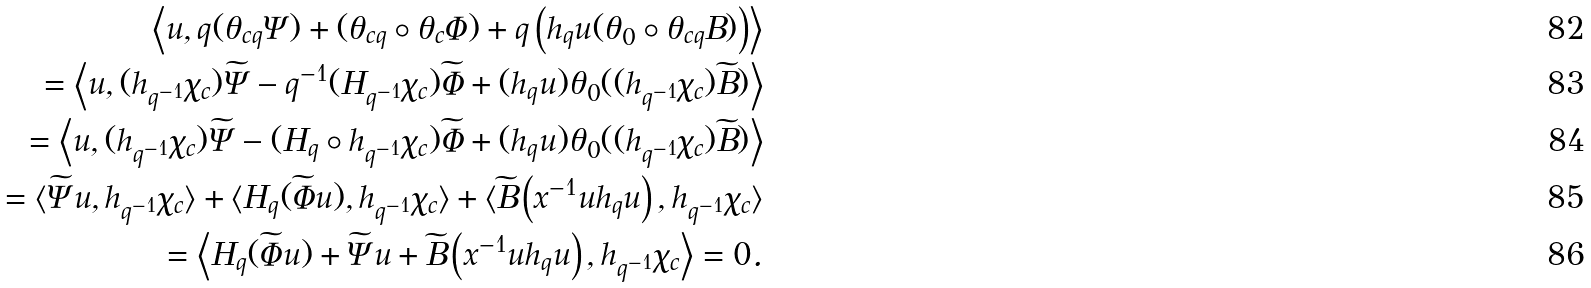Convert formula to latex. <formula><loc_0><loc_0><loc_500><loc_500>\left \langle u , q ( \theta _ { c q } \Psi ) + ( \theta _ { c q } \circ \theta _ { c } \Phi ) + q \left ( h _ { q } u ( \theta _ { 0 } \circ \theta _ { c q } B ) \right ) \right \rangle \\ = \left \langle u , ( h _ { q ^ { - 1 } } \chi _ { c } ) \widetilde { \Psi } - q ^ { - 1 } ( H _ { q ^ { - 1 } } \chi _ { c } ) \widetilde { \Phi } + ( h _ { q } u ) \theta _ { 0 } ( ( h _ { q ^ { - 1 } } \chi _ { c } ) \widetilde { B } ) \right \rangle \\ = \left \langle u , ( h _ { q ^ { - 1 } } \chi _ { c } ) \widetilde { \Psi } - ( H _ { q } \circ h _ { q ^ { - 1 } } \chi _ { c } ) \widetilde { \Phi } + ( h _ { q } u ) \theta _ { 0 } ( ( h _ { q ^ { - 1 } } \chi _ { c } ) \widetilde { B } ) \right \rangle \\ = \langle \widetilde { \Psi } u , h _ { q ^ { - 1 } } \chi _ { c } \rangle + \langle H _ { q } ( \widetilde { \Phi } u ) , h _ { q ^ { - 1 } } \chi _ { c } \rangle + \langle \widetilde { B } \left ( x ^ { - 1 } u h _ { q } u \right ) , h _ { q ^ { - 1 } } \chi _ { c } \rangle \\ = \left \langle H _ { q } ( \widetilde { \Phi } u ) + \widetilde { \Psi } u + \widetilde { B } \left ( x ^ { - 1 } u h _ { q } u \right ) , h _ { q ^ { - 1 } } \chi _ { c } \right \rangle = 0 .</formula> 